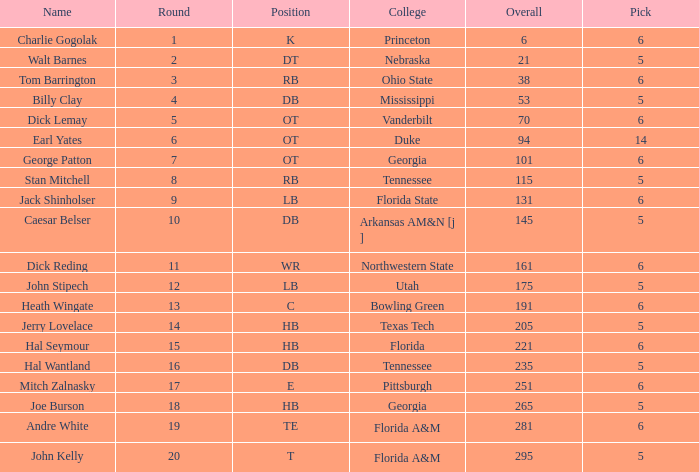What is the highest Pick, when Round is greater than 15, and when College is "Tennessee"? 5.0. 